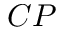Convert formula to latex. <formula><loc_0><loc_0><loc_500><loc_500>C P</formula> 